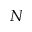<formula> <loc_0><loc_0><loc_500><loc_500>N</formula> 